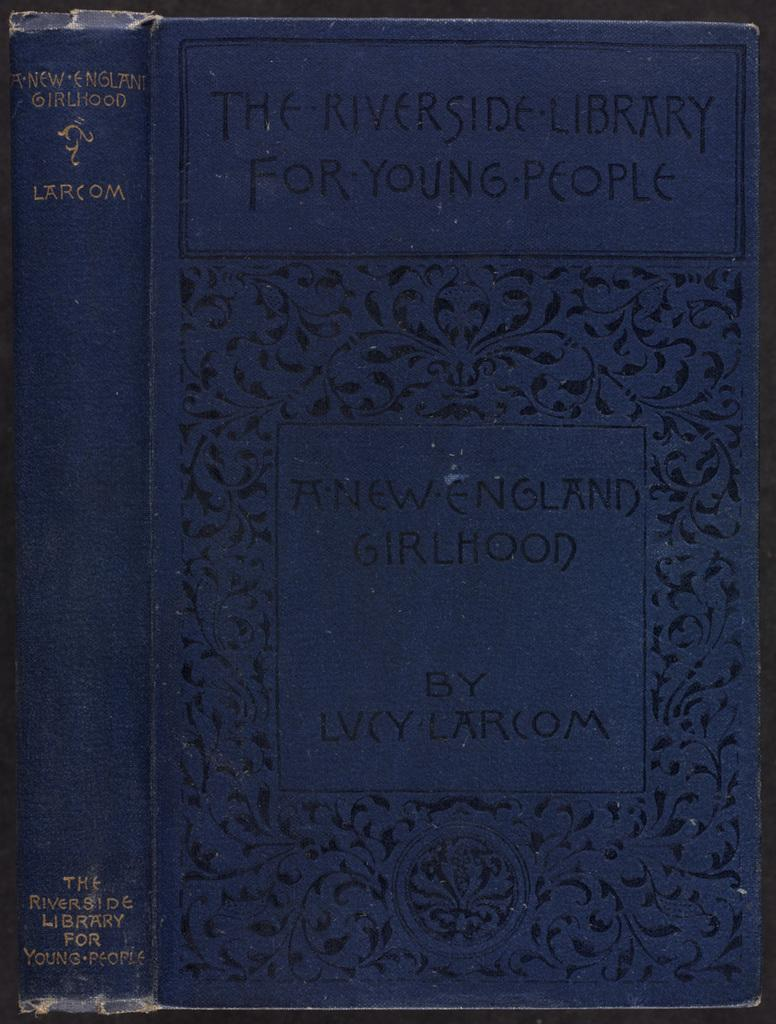<image>
Summarize the visual content of the image. a book that has the title ' the riverside library for young people' on it 